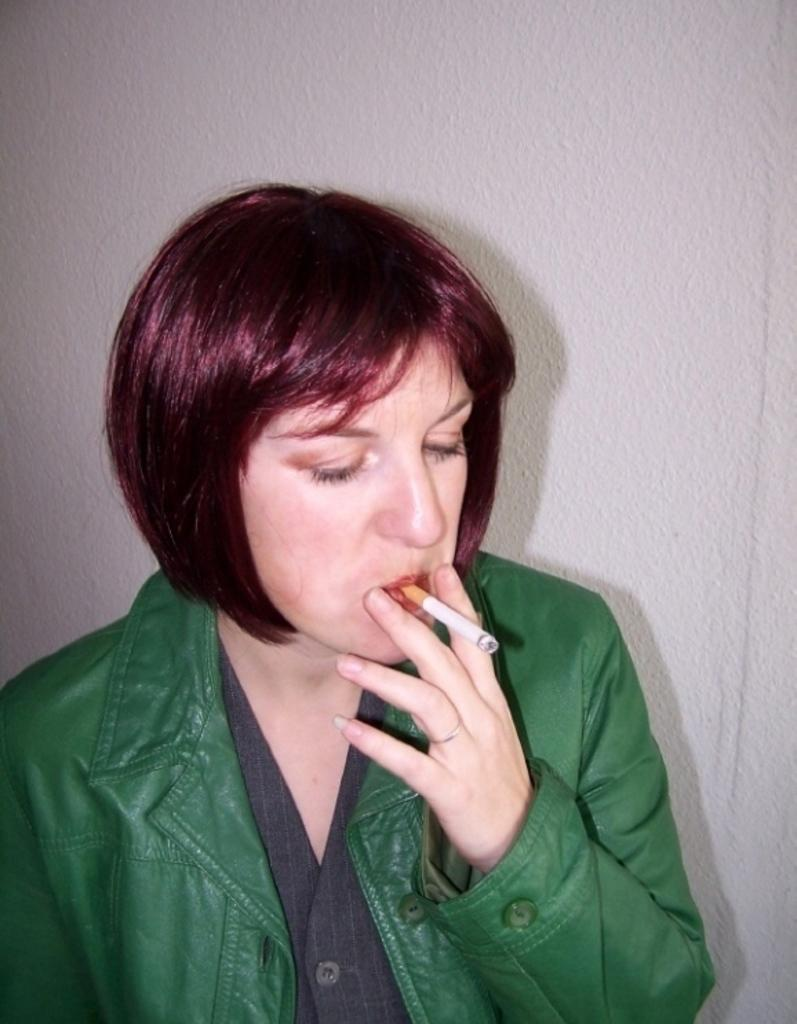Who or what is the main subject in the image? There is a person in the image. What is behind the person in the image? The person is in front of a wall. What is the person wearing in the image? The person is wearing clothes. What is the person holding in their mouth in the image? The person is holding a cigarette in their mouth. What type of cheese is the person holding in their hand in the image? There is no cheese present in the image; the person is holding a cigarette in their mouth. 